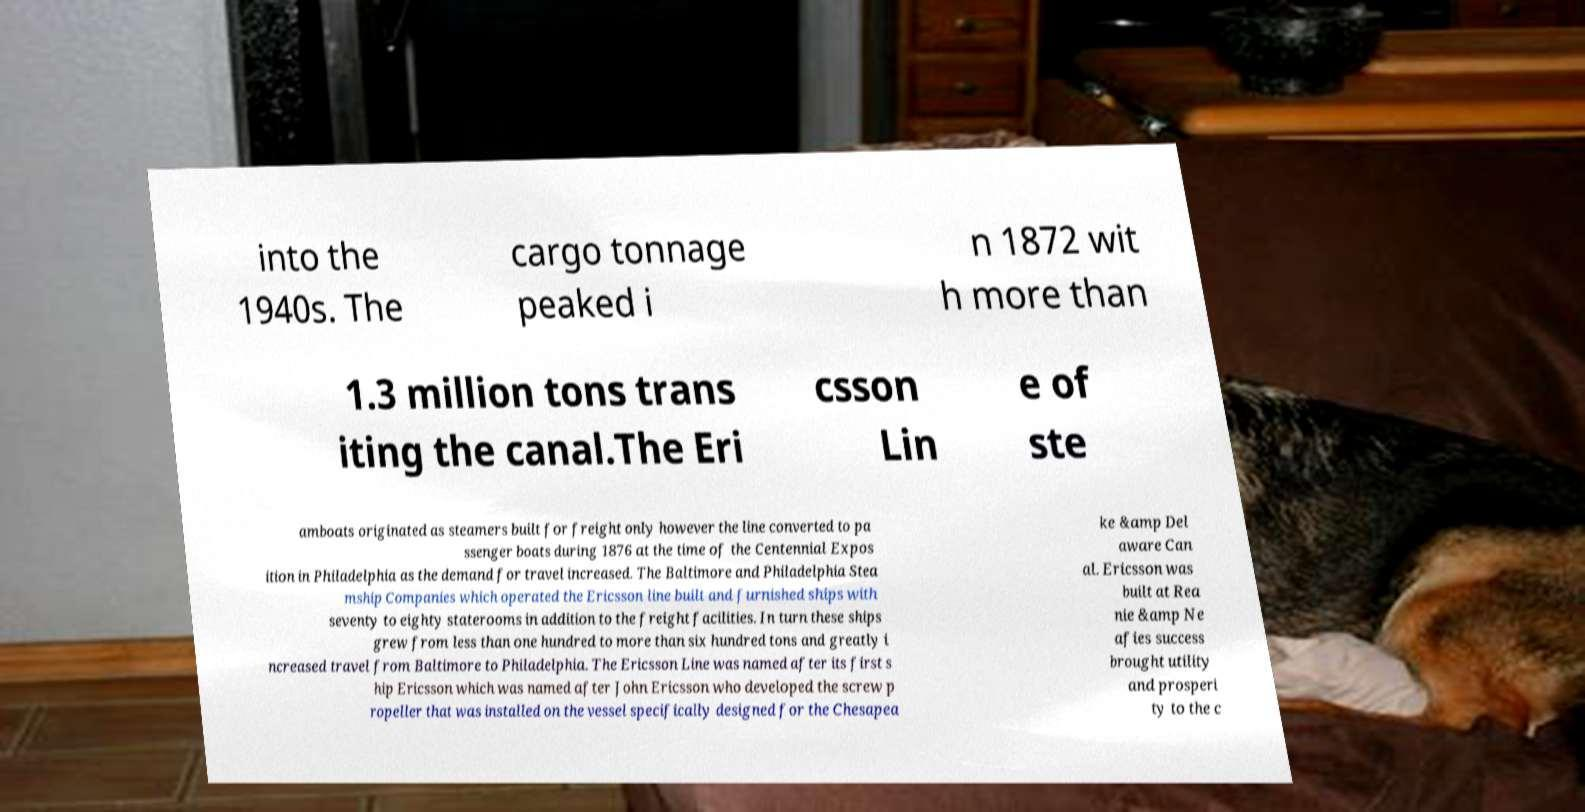There's text embedded in this image that I need extracted. Can you transcribe it verbatim? into the 1940s. The cargo tonnage peaked i n 1872 wit h more than 1.3 million tons trans iting the canal.The Eri csson Lin e of ste amboats originated as steamers built for freight only however the line converted to pa ssenger boats during 1876 at the time of the Centennial Expos ition in Philadelphia as the demand for travel increased. The Baltimore and Philadelphia Stea mship Companies which operated the Ericsson line built and furnished ships with seventy to eighty staterooms in addition to the freight facilities. In turn these ships grew from less than one hundred to more than six hundred tons and greatly i ncreased travel from Baltimore to Philadelphia. The Ericsson Line was named after its first s hip Ericsson which was named after John Ericsson who developed the screw p ropeller that was installed on the vessel specifically designed for the Chesapea ke &amp Del aware Can al. Ericsson was built at Rea nie &amp Ne afies success brought utility and prosperi ty to the c 